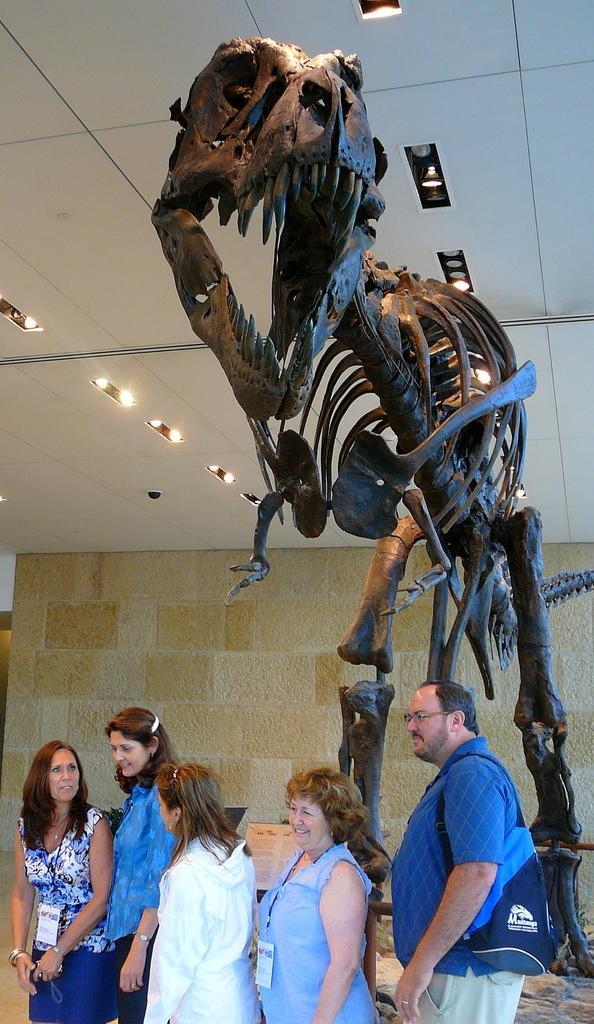Please provide a concise description of this image. This is an inside view. At the bottom of the image I can see four women and one man standing. On the right side I can see the skeleton of a dinosaur. In the background there is a wall. At the top I can see the lights. 